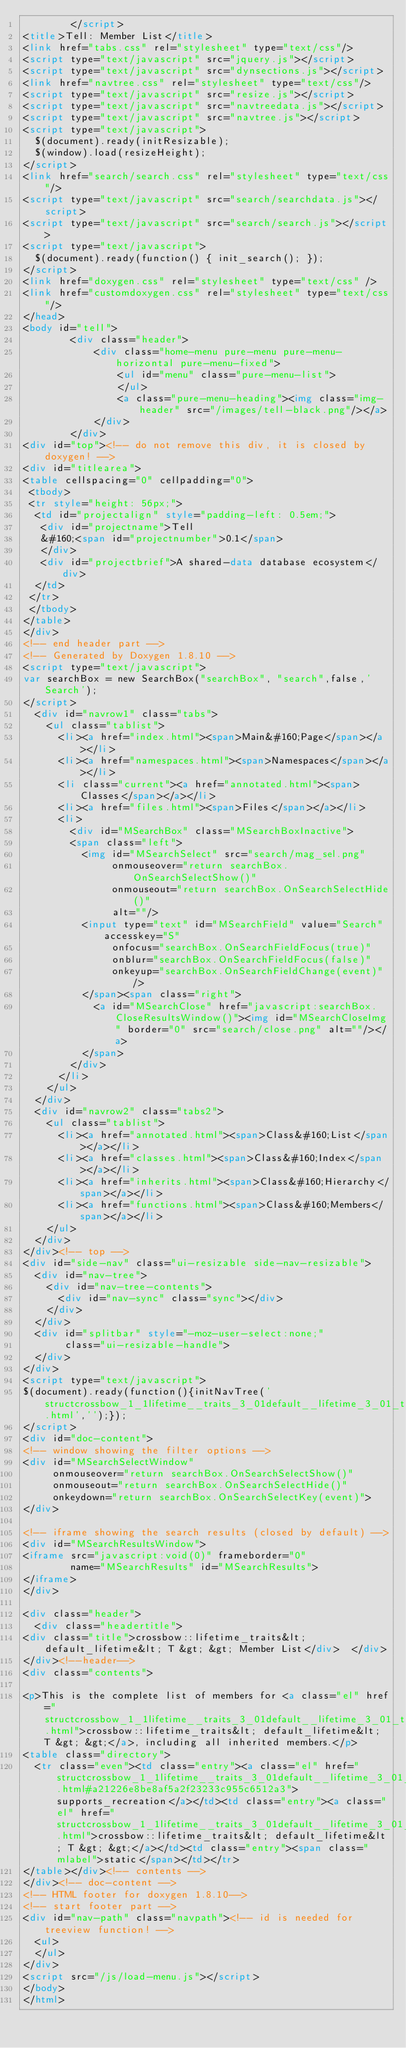Convert code to text. <code><loc_0><loc_0><loc_500><loc_500><_HTML_>        </script>
<title>Tell: Member List</title>
<link href="tabs.css" rel="stylesheet" type="text/css"/>
<script type="text/javascript" src="jquery.js"></script>
<script type="text/javascript" src="dynsections.js"></script>
<link href="navtree.css" rel="stylesheet" type="text/css"/>
<script type="text/javascript" src="resize.js"></script>
<script type="text/javascript" src="navtreedata.js"></script>
<script type="text/javascript" src="navtree.js"></script>
<script type="text/javascript">
  $(document).ready(initResizable);
  $(window).load(resizeHeight);
</script>
<link href="search/search.css" rel="stylesheet" type="text/css"/>
<script type="text/javascript" src="search/searchdata.js"></script>
<script type="text/javascript" src="search/search.js"></script>
<script type="text/javascript">
  $(document).ready(function() { init_search(); });
</script>
<link href="doxygen.css" rel="stylesheet" type="text/css" />
<link href="customdoxygen.css" rel="stylesheet" type="text/css"/>
</head>
<body id="tell">
        <div class="header">
            <div class="home-menu pure-menu pure-menu-horizontal pure-menu-fixed">
                <ul id="menu" class="pure-menu-list">
                </ul>
                <a class="pure-menu-heading"><img class="img-header" src="/images/tell-black.png"/></a>
            </div>
        </div>
<div id="top"><!-- do not remove this div, it is closed by doxygen! -->
<div id="titlearea">
<table cellspacing="0" cellpadding="0">
 <tbody>
 <tr style="height: 56px;">
  <td id="projectalign" style="padding-left: 0.5em;">
   <div id="projectname">Tell
   &#160;<span id="projectnumber">0.1</span>
   </div>
   <div id="projectbrief">A shared-data database ecosystem</div>
  </td>
 </tr>
 </tbody>
</table>
</div>
<!-- end header part -->
<!-- Generated by Doxygen 1.8.10 -->
<script type="text/javascript">
var searchBox = new SearchBox("searchBox", "search",false,'Search');
</script>
  <div id="navrow1" class="tabs">
    <ul class="tablist">
      <li><a href="index.html"><span>Main&#160;Page</span></a></li>
      <li><a href="namespaces.html"><span>Namespaces</span></a></li>
      <li class="current"><a href="annotated.html"><span>Classes</span></a></li>
      <li><a href="files.html"><span>Files</span></a></li>
      <li>
        <div id="MSearchBox" class="MSearchBoxInactive">
        <span class="left">
          <img id="MSearchSelect" src="search/mag_sel.png"
               onmouseover="return searchBox.OnSearchSelectShow()"
               onmouseout="return searchBox.OnSearchSelectHide()"
               alt=""/>
          <input type="text" id="MSearchField" value="Search" accesskey="S"
               onfocus="searchBox.OnSearchFieldFocus(true)" 
               onblur="searchBox.OnSearchFieldFocus(false)" 
               onkeyup="searchBox.OnSearchFieldChange(event)"/>
          </span><span class="right">
            <a id="MSearchClose" href="javascript:searchBox.CloseResultsWindow()"><img id="MSearchCloseImg" border="0" src="search/close.png" alt=""/></a>
          </span>
        </div>
      </li>
    </ul>
  </div>
  <div id="navrow2" class="tabs2">
    <ul class="tablist">
      <li><a href="annotated.html"><span>Class&#160;List</span></a></li>
      <li><a href="classes.html"><span>Class&#160;Index</span></a></li>
      <li><a href="inherits.html"><span>Class&#160;Hierarchy</span></a></li>
      <li><a href="functions.html"><span>Class&#160;Members</span></a></li>
    </ul>
  </div>
</div><!-- top -->
<div id="side-nav" class="ui-resizable side-nav-resizable">
  <div id="nav-tree">
    <div id="nav-tree-contents">
      <div id="nav-sync" class="sync"></div>
    </div>
  </div>
  <div id="splitbar" style="-moz-user-select:none;" 
       class="ui-resizable-handle">
  </div>
</div>
<script type="text/javascript">
$(document).ready(function(){initNavTree('structcrossbow_1_1lifetime__traits_3_01default__lifetime_3_01_t_01_4_01_4.html','');});
</script>
<div id="doc-content">
<!-- window showing the filter options -->
<div id="MSearchSelectWindow"
     onmouseover="return searchBox.OnSearchSelectShow()"
     onmouseout="return searchBox.OnSearchSelectHide()"
     onkeydown="return searchBox.OnSearchSelectKey(event)">
</div>

<!-- iframe showing the search results (closed by default) -->
<div id="MSearchResultsWindow">
<iframe src="javascript:void(0)" frameborder="0" 
        name="MSearchResults" id="MSearchResults">
</iframe>
</div>

<div class="header">
  <div class="headertitle">
<div class="title">crossbow::lifetime_traits&lt; default_lifetime&lt; T &gt; &gt; Member List</div>  </div>
</div><!--header-->
<div class="contents">

<p>This is the complete list of members for <a class="el" href="structcrossbow_1_1lifetime__traits_3_01default__lifetime_3_01_t_01_4_01_4.html">crossbow::lifetime_traits&lt; default_lifetime&lt; T &gt; &gt;</a>, including all inherited members.</p>
<table class="directory">
  <tr class="even"><td class="entry"><a class="el" href="structcrossbow_1_1lifetime__traits_3_01default__lifetime_3_01_t_01_4_01_4.html#a21226e8be8af5a2f23233c955c6512a3">supports_recreation</a></td><td class="entry"><a class="el" href="structcrossbow_1_1lifetime__traits_3_01default__lifetime_3_01_t_01_4_01_4.html">crossbow::lifetime_traits&lt; default_lifetime&lt; T &gt; &gt;</a></td><td class="entry"><span class="mlabel">static</span></td></tr>
</table></div><!-- contents -->
</div><!-- doc-content -->
<!-- HTML footer for doxygen 1.8.10-->
<!-- start footer part -->
<div id="nav-path" class="navpath"><!-- id is needed for treeview function! -->
  <ul>
  </ul>
</div>
<script src="/js/load-menu.js"></script>
</body>
</html>
</code> 